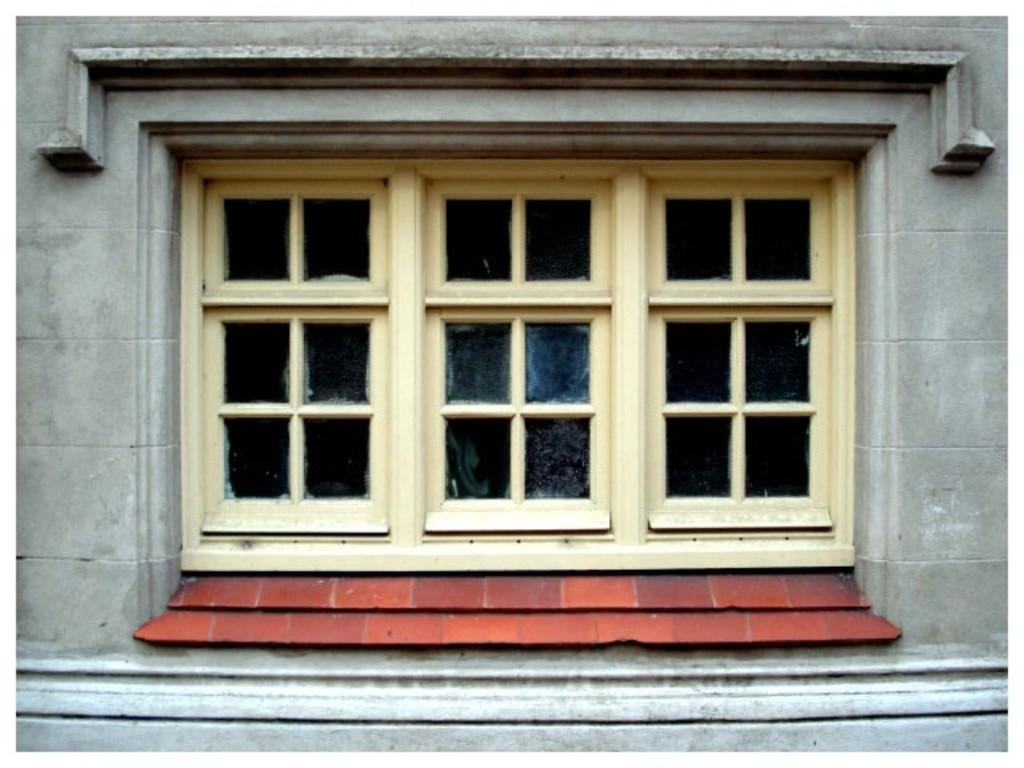What can be seen in the center of the image? There are windows in the center of the image. What is located at the bottom of the image? There is a well at the bottom of the image. What is located at the top of the image? There is a well at the top of the image. What type of pleasure can be seen in the image? There is no reference to pleasure in the image, as it features windows and wells. What does the well at the look like in the image? The wells in the image are not described in terms of their appearance, so it is not possible to answer this question definitively. 